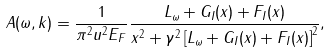<formula> <loc_0><loc_0><loc_500><loc_500>A ( \omega , k ) = \frac { 1 } { \pi ^ { 2 } u ^ { 2 } E _ { F } } \frac { L _ { \omega } + G _ { I } ( x ) + F _ { I } ( x ) } { x ^ { 2 } + \gamma ^ { 2 } \left [ L _ { \omega } + G _ { I } ( x ) + F _ { I } ( x ) \right ] ^ { 2 } } ,</formula> 